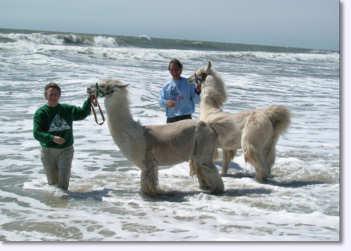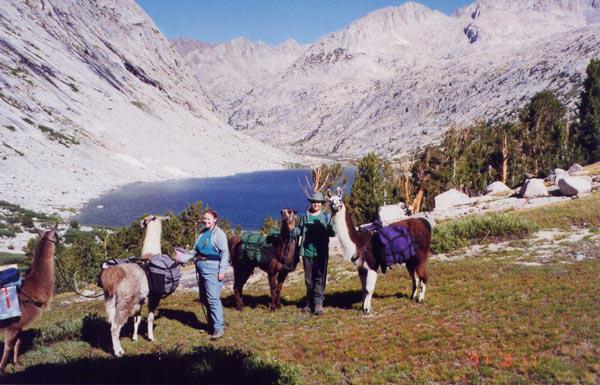The first image is the image on the left, the second image is the image on the right. Assess this claim about the two images: "There is a man in camouflage leading a pack of llamas through the snow, the llamas are wearing packs on their backs". Correct or not? Answer yes or no. No. 